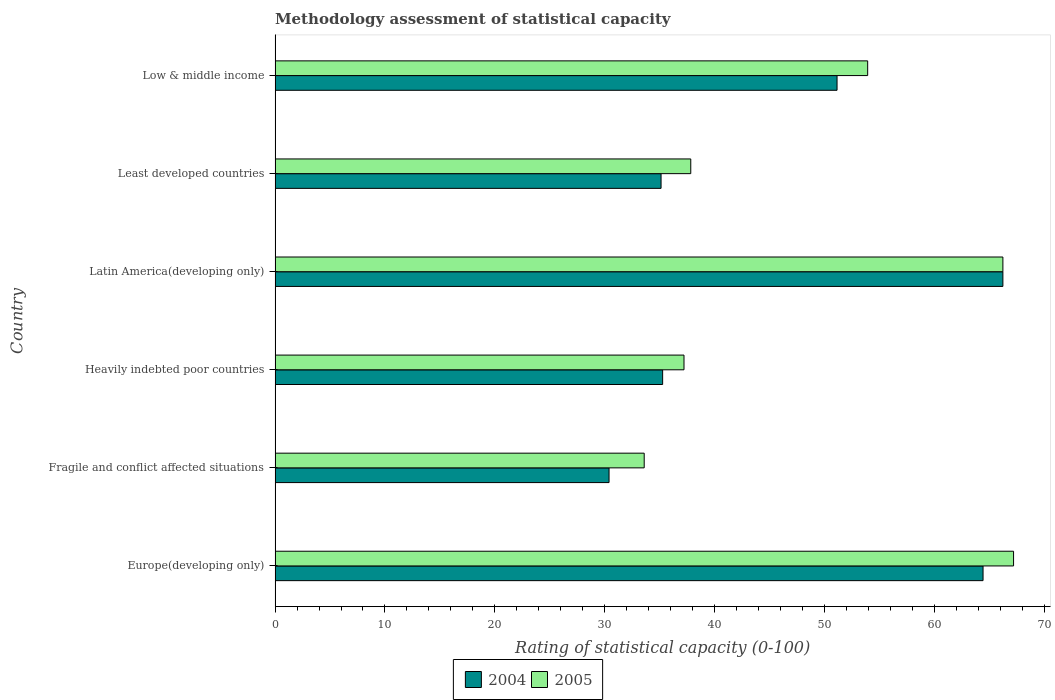Are the number of bars on each tick of the Y-axis equal?
Your answer should be very brief. Yes. How many bars are there on the 4th tick from the bottom?
Make the answer very short. 2. What is the label of the 6th group of bars from the top?
Keep it short and to the point. Europe(developing only). What is the rating of statistical capacity in 2004 in Europe(developing only)?
Provide a short and direct response. 64.44. Across all countries, what is the maximum rating of statistical capacity in 2005?
Make the answer very short. 67.22. Across all countries, what is the minimum rating of statistical capacity in 2004?
Your response must be concise. 30.4. In which country was the rating of statistical capacity in 2005 maximum?
Make the answer very short. Europe(developing only). In which country was the rating of statistical capacity in 2005 minimum?
Make the answer very short. Fragile and conflict affected situations. What is the total rating of statistical capacity in 2005 in the graph?
Provide a succinct answer. 296.07. What is the difference between the rating of statistical capacity in 2005 in Fragile and conflict affected situations and that in Heavily indebted poor countries?
Provide a short and direct response. -3.62. What is the difference between the rating of statistical capacity in 2004 in Europe(developing only) and the rating of statistical capacity in 2005 in Least developed countries?
Ensure brevity in your answer.  26.61. What is the average rating of statistical capacity in 2005 per country?
Ensure brevity in your answer.  49.35. What is the difference between the rating of statistical capacity in 2004 and rating of statistical capacity in 2005 in Heavily indebted poor countries?
Provide a succinct answer. -1.94. In how many countries, is the rating of statistical capacity in 2005 greater than 24 ?
Provide a succinct answer. 6. What is the ratio of the rating of statistical capacity in 2005 in Fragile and conflict affected situations to that in Latin America(developing only)?
Keep it short and to the point. 0.51. Is the rating of statistical capacity in 2004 in Heavily indebted poor countries less than that in Least developed countries?
Your response must be concise. No. What is the difference between the highest and the second highest rating of statistical capacity in 2005?
Make the answer very short. 0.97. What is the difference between the highest and the lowest rating of statistical capacity in 2004?
Provide a succinct answer. 35.85. In how many countries, is the rating of statistical capacity in 2005 greater than the average rating of statistical capacity in 2005 taken over all countries?
Give a very brief answer. 3. Are all the bars in the graph horizontal?
Your answer should be very brief. Yes. Are the values on the major ticks of X-axis written in scientific E-notation?
Your answer should be compact. No. Does the graph contain any zero values?
Offer a very short reply. No. Does the graph contain grids?
Ensure brevity in your answer.  No. How many legend labels are there?
Give a very brief answer. 2. How are the legend labels stacked?
Keep it short and to the point. Horizontal. What is the title of the graph?
Keep it short and to the point. Methodology assessment of statistical capacity. What is the label or title of the X-axis?
Provide a succinct answer. Rating of statistical capacity (0-100). What is the label or title of the Y-axis?
Your answer should be very brief. Country. What is the Rating of statistical capacity (0-100) of 2004 in Europe(developing only)?
Give a very brief answer. 64.44. What is the Rating of statistical capacity (0-100) in 2005 in Europe(developing only)?
Keep it short and to the point. 67.22. What is the Rating of statistical capacity (0-100) of 2004 in Fragile and conflict affected situations?
Ensure brevity in your answer.  30.4. What is the Rating of statistical capacity (0-100) of 2005 in Fragile and conflict affected situations?
Keep it short and to the point. 33.6. What is the Rating of statistical capacity (0-100) of 2004 in Heavily indebted poor countries?
Your response must be concise. 35.28. What is the Rating of statistical capacity (0-100) of 2005 in Heavily indebted poor countries?
Give a very brief answer. 37.22. What is the Rating of statistical capacity (0-100) in 2004 in Latin America(developing only)?
Offer a terse response. 66.25. What is the Rating of statistical capacity (0-100) of 2005 in Latin America(developing only)?
Your answer should be compact. 66.25. What is the Rating of statistical capacity (0-100) of 2004 in Least developed countries?
Your answer should be compact. 35.14. What is the Rating of statistical capacity (0-100) of 2005 in Least developed countries?
Your answer should be compact. 37.84. What is the Rating of statistical capacity (0-100) in 2004 in Low & middle income?
Provide a short and direct response. 51.15. What is the Rating of statistical capacity (0-100) in 2005 in Low & middle income?
Your answer should be very brief. 53.94. Across all countries, what is the maximum Rating of statistical capacity (0-100) in 2004?
Provide a short and direct response. 66.25. Across all countries, what is the maximum Rating of statistical capacity (0-100) in 2005?
Your answer should be compact. 67.22. Across all countries, what is the minimum Rating of statistical capacity (0-100) in 2004?
Make the answer very short. 30.4. Across all countries, what is the minimum Rating of statistical capacity (0-100) of 2005?
Keep it short and to the point. 33.6. What is the total Rating of statistical capacity (0-100) of 2004 in the graph?
Provide a succinct answer. 282.66. What is the total Rating of statistical capacity (0-100) of 2005 in the graph?
Your response must be concise. 296.07. What is the difference between the Rating of statistical capacity (0-100) of 2004 in Europe(developing only) and that in Fragile and conflict affected situations?
Your answer should be very brief. 34.04. What is the difference between the Rating of statistical capacity (0-100) in 2005 in Europe(developing only) and that in Fragile and conflict affected situations?
Your answer should be compact. 33.62. What is the difference between the Rating of statistical capacity (0-100) of 2004 in Europe(developing only) and that in Heavily indebted poor countries?
Keep it short and to the point. 29.17. What is the difference between the Rating of statistical capacity (0-100) of 2004 in Europe(developing only) and that in Latin America(developing only)?
Provide a short and direct response. -1.81. What is the difference between the Rating of statistical capacity (0-100) of 2005 in Europe(developing only) and that in Latin America(developing only)?
Provide a short and direct response. 0.97. What is the difference between the Rating of statistical capacity (0-100) in 2004 in Europe(developing only) and that in Least developed countries?
Your answer should be compact. 29.31. What is the difference between the Rating of statistical capacity (0-100) in 2005 in Europe(developing only) and that in Least developed countries?
Ensure brevity in your answer.  29.38. What is the difference between the Rating of statistical capacity (0-100) of 2004 in Europe(developing only) and that in Low & middle income?
Your answer should be compact. 13.29. What is the difference between the Rating of statistical capacity (0-100) of 2005 in Europe(developing only) and that in Low & middle income?
Your response must be concise. 13.28. What is the difference between the Rating of statistical capacity (0-100) in 2004 in Fragile and conflict affected situations and that in Heavily indebted poor countries?
Your answer should be compact. -4.88. What is the difference between the Rating of statistical capacity (0-100) in 2005 in Fragile and conflict affected situations and that in Heavily indebted poor countries?
Provide a short and direct response. -3.62. What is the difference between the Rating of statistical capacity (0-100) in 2004 in Fragile and conflict affected situations and that in Latin America(developing only)?
Provide a short and direct response. -35.85. What is the difference between the Rating of statistical capacity (0-100) of 2005 in Fragile and conflict affected situations and that in Latin America(developing only)?
Keep it short and to the point. -32.65. What is the difference between the Rating of statistical capacity (0-100) in 2004 in Fragile and conflict affected situations and that in Least developed countries?
Give a very brief answer. -4.74. What is the difference between the Rating of statistical capacity (0-100) in 2005 in Fragile and conflict affected situations and that in Least developed countries?
Offer a terse response. -4.24. What is the difference between the Rating of statistical capacity (0-100) of 2004 in Fragile and conflict affected situations and that in Low & middle income?
Offer a very short reply. -20.75. What is the difference between the Rating of statistical capacity (0-100) of 2005 in Fragile and conflict affected situations and that in Low & middle income?
Offer a very short reply. -20.34. What is the difference between the Rating of statistical capacity (0-100) of 2004 in Heavily indebted poor countries and that in Latin America(developing only)?
Make the answer very short. -30.97. What is the difference between the Rating of statistical capacity (0-100) of 2005 in Heavily indebted poor countries and that in Latin America(developing only)?
Provide a short and direct response. -29.03. What is the difference between the Rating of statistical capacity (0-100) of 2004 in Heavily indebted poor countries and that in Least developed countries?
Provide a short and direct response. 0.14. What is the difference between the Rating of statistical capacity (0-100) in 2005 in Heavily indebted poor countries and that in Least developed countries?
Give a very brief answer. -0.62. What is the difference between the Rating of statistical capacity (0-100) of 2004 in Heavily indebted poor countries and that in Low & middle income?
Ensure brevity in your answer.  -15.88. What is the difference between the Rating of statistical capacity (0-100) of 2005 in Heavily indebted poor countries and that in Low & middle income?
Keep it short and to the point. -16.72. What is the difference between the Rating of statistical capacity (0-100) of 2004 in Latin America(developing only) and that in Least developed countries?
Ensure brevity in your answer.  31.11. What is the difference between the Rating of statistical capacity (0-100) in 2005 in Latin America(developing only) and that in Least developed countries?
Offer a terse response. 28.41. What is the difference between the Rating of statistical capacity (0-100) of 2004 in Latin America(developing only) and that in Low & middle income?
Give a very brief answer. 15.1. What is the difference between the Rating of statistical capacity (0-100) of 2005 in Latin America(developing only) and that in Low & middle income?
Your answer should be compact. 12.31. What is the difference between the Rating of statistical capacity (0-100) of 2004 in Least developed countries and that in Low & middle income?
Your answer should be compact. -16.02. What is the difference between the Rating of statistical capacity (0-100) in 2005 in Least developed countries and that in Low & middle income?
Keep it short and to the point. -16.1. What is the difference between the Rating of statistical capacity (0-100) of 2004 in Europe(developing only) and the Rating of statistical capacity (0-100) of 2005 in Fragile and conflict affected situations?
Keep it short and to the point. 30.84. What is the difference between the Rating of statistical capacity (0-100) of 2004 in Europe(developing only) and the Rating of statistical capacity (0-100) of 2005 in Heavily indebted poor countries?
Make the answer very short. 27.22. What is the difference between the Rating of statistical capacity (0-100) of 2004 in Europe(developing only) and the Rating of statistical capacity (0-100) of 2005 in Latin America(developing only)?
Offer a terse response. -1.81. What is the difference between the Rating of statistical capacity (0-100) in 2004 in Europe(developing only) and the Rating of statistical capacity (0-100) in 2005 in Least developed countries?
Give a very brief answer. 26.61. What is the difference between the Rating of statistical capacity (0-100) in 2004 in Europe(developing only) and the Rating of statistical capacity (0-100) in 2005 in Low & middle income?
Keep it short and to the point. 10.5. What is the difference between the Rating of statistical capacity (0-100) of 2004 in Fragile and conflict affected situations and the Rating of statistical capacity (0-100) of 2005 in Heavily indebted poor countries?
Keep it short and to the point. -6.82. What is the difference between the Rating of statistical capacity (0-100) in 2004 in Fragile and conflict affected situations and the Rating of statistical capacity (0-100) in 2005 in Latin America(developing only)?
Offer a very short reply. -35.85. What is the difference between the Rating of statistical capacity (0-100) in 2004 in Fragile and conflict affected situations and the Rating of statistical capacity (0-100) in 2005 in Least developed countries?
Offer a terse response. -7.44. What is the difference between the Rating of statistical capacity (0-100) of 2004 in Fragile and conflict affected situations and the Rating of statistical capacity (0-100) of 2005 in Low & middle income?
Your answer should be very brief. -23.54. What is the difference between the Rating of statistical capacity (0-100) in 2004 in Heavily indebted poor countries and the Rating of statistical capacity (0-100) in 2005 in Latin America(developing only)?
Your answer should be compact. -30.97. What is the difference between the Rating of statistical capacity (0-100) of 2004 in Heavily indebted poor countries and the Rating of statistical capacity (0-100) of 2005 in Least developed countries?
Your answer should be compact. -2.56. What is the difference between the Rating of statistical capacity (0-100) in 2004 in Heavily indebted poor countries and the Rating of statistical capacity (0-100) in 2005 in Low & middle income?
Ensure brevity in your answer.  -18.66. What is the difference between the Rating of statistical capacity (0-100) in 2004 in Latin America(developing only) and the Rating of statistical capacity (0-100) in 2005 in Least developed countries?
Your response must be concise. 28.41. What is the difference between the Rating of statistical capacity (0-100) in 2004 in Latin America(developing only) and the Rating of statistical capacity (0-100) in 2005 in Low & middle income?
Make the answer very short. 12.31. What is the difference between the Rating of statistical capacity (0-100) of 2004 in Least developed countries and the Rating of statistical capacity (0-100) of 2005 in Low & middle income?
Ensure brevity in your answer.  -18.81. What is the average Rating of statistical capacity (0-100) in 2004 per country?
Your answer should be very brief. 47.11. What is the average Rating of statistical capacity (0-100) of 2005 per country?
Your response must be concise. 49.35. What is the difference between the Rating of statistical capacity (0-100) in 2004 and Rating of statistical capacity (0-100) in 2005 in Europe(developing only)?
Your response must be concise. -2.78. What is the difference between the Rating of statistical capacity (0-100) in 2004 and Rating of statistical capacity (0-100) in 2005 in Fragile and conflict affected situations?
Offer a terse response. -3.2. What is the difference between the Rating of statistical capacity (0-100) in 2004 and Rating of statistical capacity (0-100) in 2005 in Heavily indebted poor countries?
Provide a succinct answer. -1.94. What is the difference between the Rating of statistical capacity (0-100) of 2004 and Rating of statistical capacity (0-100) of 2005 in Latin America(developing only)?
Keep it short and to the point. 0. What is the difference between the Rating of statistical capacity (0-100) of 2004 and Rating of statistical capacity (0-100) of 2005 in Least developed countries?
Provide a short and direct response. -2.7. What is the difference between the Rating of statistical capacity (0-100) of 2004 and Rating of statistical capacity (0-100) of 2005 in Low & middle income?
Make the answer very short. -2.79. What is the ratio of the Rating of statistical capacity (0-100) in 2004 in Europe(developing only) to that in Fragile and conflict affected situations?
Ensure brevity in your answer.  2.12. What is the ratio of the Rating of statistical capacity (0-100) in 2005 in Europe(developing only) to that in Fragile and conflict affected situations?
Provide a short and direct response. 2. What is the ratio of the Rating of statistical capacity (0-100) in 2004 in Europe(developing only) to that in Heavily indebted poor countries?
Ensure brevity in your answer.  1.83. What is the ratio of the Rating of statistical capacity (0-100) in 2005 in Europe(developing only) to that in Heavily indebted poor countries?
Offer a terse response. 1.81. What is the ratio of the Rating of statistical capacity (0-100) of 2004 in Europe(developing only) to that in Latin America(developing only)?
Your response must be concise. 0.97. What is the ratio of the Rating of statistical capacity (0-100) in 2005 in Europe(developing only) to that in Latin America(developing only)?
Offer a very short reply. 1.01. What is the ratio of the Rating of statistical capacity (0-100) of 2004 in Europe(developing only) to that in Least developed countries?
Your answer should be compact. 1.83. What is the ratio of the Rating of statistical capacity (0-100) in 2005 in Europe(developing only) to that in Least developed countries?
Offer a very short reply. 1.78. What is the ratio of the Rating of statistical capacity (0-100) of 2004 in Europe(developing only) to that in Low & middle income?
Your answer should be very brief. 1.26. What is the ratio of the Rating of statistical capacity (0-100) of 2005 in Europe(developing only) to that in Low & middle income?
Provide a succinct answer. 1.25. What is the ratio of the Rating of statistical capacity (0-100) of 2004 in Fragile and conflict affected situations to that in Heavily indebted poor countries?
Provide a succinct answer. 0.86. What is the ratio of the Rating of statistical capacity (0-100) of 2005 in Fragile and conflict affected situations to that in Heavily indebted poor countries?
Keep it short and to the point. 0.9. What is the ratio of the Rating of statistical capacity (0-100) in 2004 in Fragile and conflict affected situations to that in Latin America(developing only)?
Your answer should be very brief. 0.46. What is the ratio of the Rating of statistical capacity (0-100) of 2005 in Fragile and conflict affected situations to that in Latin America(developing only)?
Provide a short and direct response. 0.51. What is the ratio of the Rating of statistical capacity (0-100) of 2004 in Fragile and conflict affected situations to that in Least developed countries?
Keep it short and to the point. 0.87. What is the ratio of the Rating of statistical capacity (0-100) of 2005 in Fragile and conflict affected situations to that in Least developed countries?
Your answer should be compact. 0.89. What is the ratio of the Rating of statistical capacity (0-100) in 2004 in Fragile and conflict affected situations to that in Low & middle income?
Ensure brevity in your answer.  0.59. What is the ratio of the Rating of statistical capacity (0-100) of 2005 in Fragile and conflict affected situations to that in Low & middle income?
Offer a terse response. 0.62. What is the ratio of the Rating of statistical capacity (0-100) in 2004 in Heavily indebted poor countries to that in Latin America(developing only)?
Offer a terse response. 0.53. What is the ratio of the Rating of statistical capacity (0-100) in 2005 in Heavily indebted poor countries to that in Latin America(developing only)?
Ensure brevity in your answer.  0.56. What is the ratio of the Rating of statistical capacity (0-100) in 2005 in Heavily indebted poor countries to that in Least developed countries?
Provide a short and direct response. 0.98. What is the ratio of the Rating of statistical capacity (0-100) in 2004 in Heavily indebted poor countries to that in Low & middle income?
Provide a succinct answer. 0.69. What is the ratio of the Rating of statistical capacity (0-100) in 2005 in Heavily indebted poor countries to that in Low & middle income?
Offer a terse response. 0.69. What is the ratio of the Rating of statistical capacity (0-100) of 2004 in Latin America(developing only) to that in Least developed countries?
Make the answer very short. 1.89. What is the ratio of the Rating of statistical capacity (0-100) of 2005 in Latin America(developing only) to that in Least developed countries?
Ensure brevity in your answer.  1.75. What is the ratio of the Rating of statistical capacity (0-100) in 2004 in Latin America(developing only) to that in Low & middle income?
Ensure brevity in your answer.  1.3. What is the ratio of the Rating of statistical capacity (0-100) of 2005 in Latin America(developing only) to that in Low & middle income?
Your answer should be compact. 1.23. What is the ratio of the Rating of statistical capacity (0-100) of 2004 in Least developed countries to that in Low & middle income?
Your answer should be very brief. 0.69. What is the ratio of the Rating of statistical capacity (0-100) of 2005 in Least developed countries to that in Low & middle income?
Keep it short and to the point. 0.7. What is the difference between the highest and the second highest Rating of statistical capacity (0-100) in 2004?
Your response must be concise. 1.81. What is the difference between the highest and the second highest Rating of statistical capacity (0-100) in 2005?
Give a very brief answer. 0.97. What is the difference between the highest and the lowest Rating of statistical capacity (0-100) in 2004?
Your answer should be very brief. 35.85. What is the difference between the highest and the lowest Rating of statistical capacity (0-100) of 2005?
Provide a short and direct response. 33.62. 